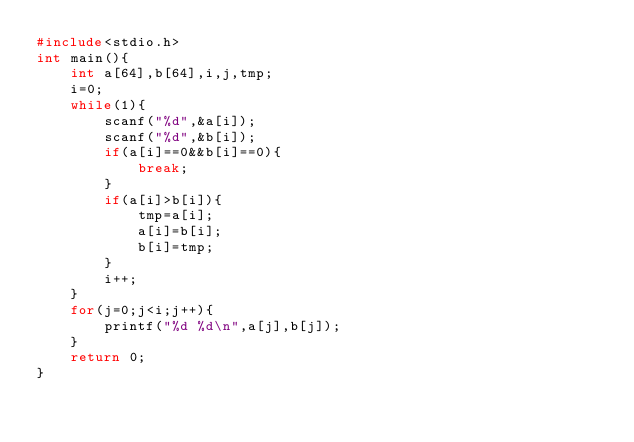Convert code to text. <code><loc_0><loc_0><loc_500><loc_500><_C_>#include<stdio.h>
int main(){
    int a[64],b[64],i,j,tmp;
    i=0;
    while(1){
        scanf("%d",&a[i]);
        scanf("%d",&b[i]);
        if(a[i]==0&&b[i]==0){
            break;
        }
        if(a[i]>b[i]){
            tmp=a[i];
            a[i]=b[i];
            b[i]=tmp;
        }
        i++;
    }
    for(j=0;j<i;j++){
        printf("%d %d\n",a[j],b[j]);
    }
    return 0;
}</code> 